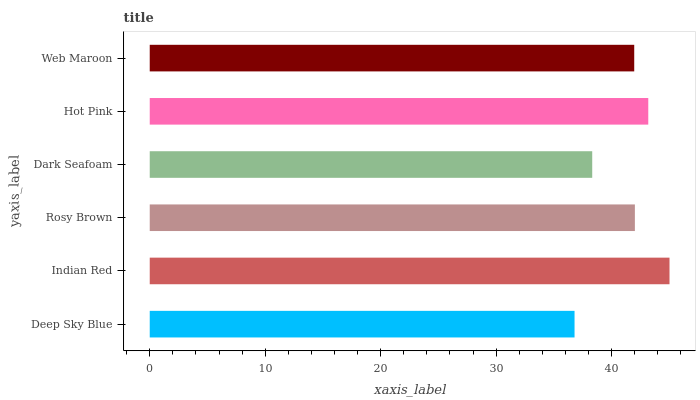Is Deep Sky Blue the minimum?
Answer yes or no. Yes. Is Indian Red the maximum?
Answer yes or no. Yes. Is Rosy Brown the minimum?
Answer yes or no. No. Is Rosy Brown the maximum?
Answer yes or no. No. Is Indian Red greater than Rosy Brown?
Answer yes or no. Yes. Is Rosy Brown less than Indian Red?
Answer yes or no. Yes. Is Rosy Brown greater than Indian Red?
Answer yes or no. No. Is Indian Red less than Rosy Brown?
Answer yes or no. No. Is Rosy Brown the high median?
Answer yes or no. Yes. Is Web Maroon the low median?
Answer yes or no. Yes. Is Deep Sky Blue the high median?
Answer yes or no. No. Is Rosy Brown the low median?
Answer yes or no. No. 